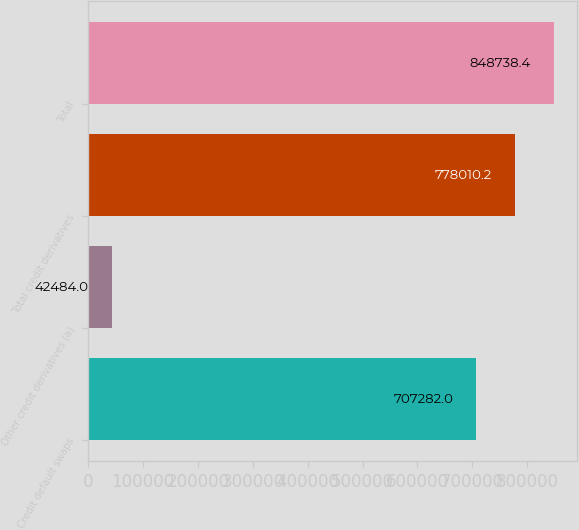Convert chart. <chart><loc_0><loc_0><loc_500><loc_500><bar_chart><fcel>Credit default swaps<fcel>Other credit derivatives (a)<fcel>Total credit derivatives<fcel>Total<nl><fcel>707282<fcel>42484<fcel>778010<fcel>848738<nl></chart> 